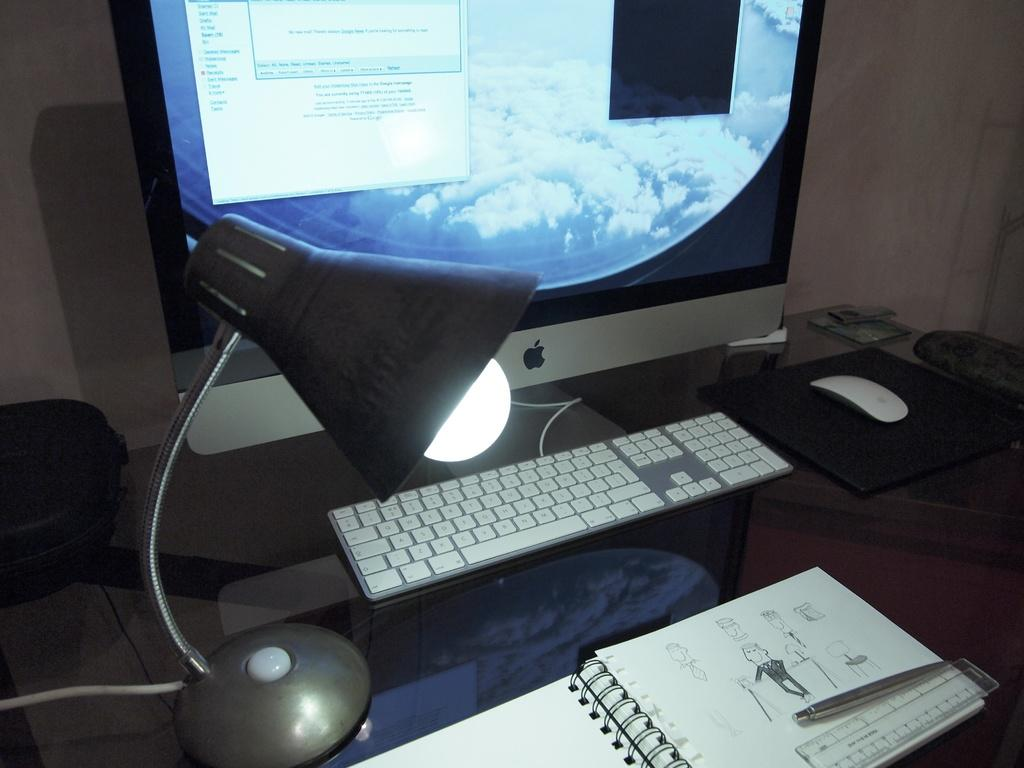<image>
Present a compact description of the photo's key features. A computer screen is open to an email program with options for sent mail, drafts, and all mail. 